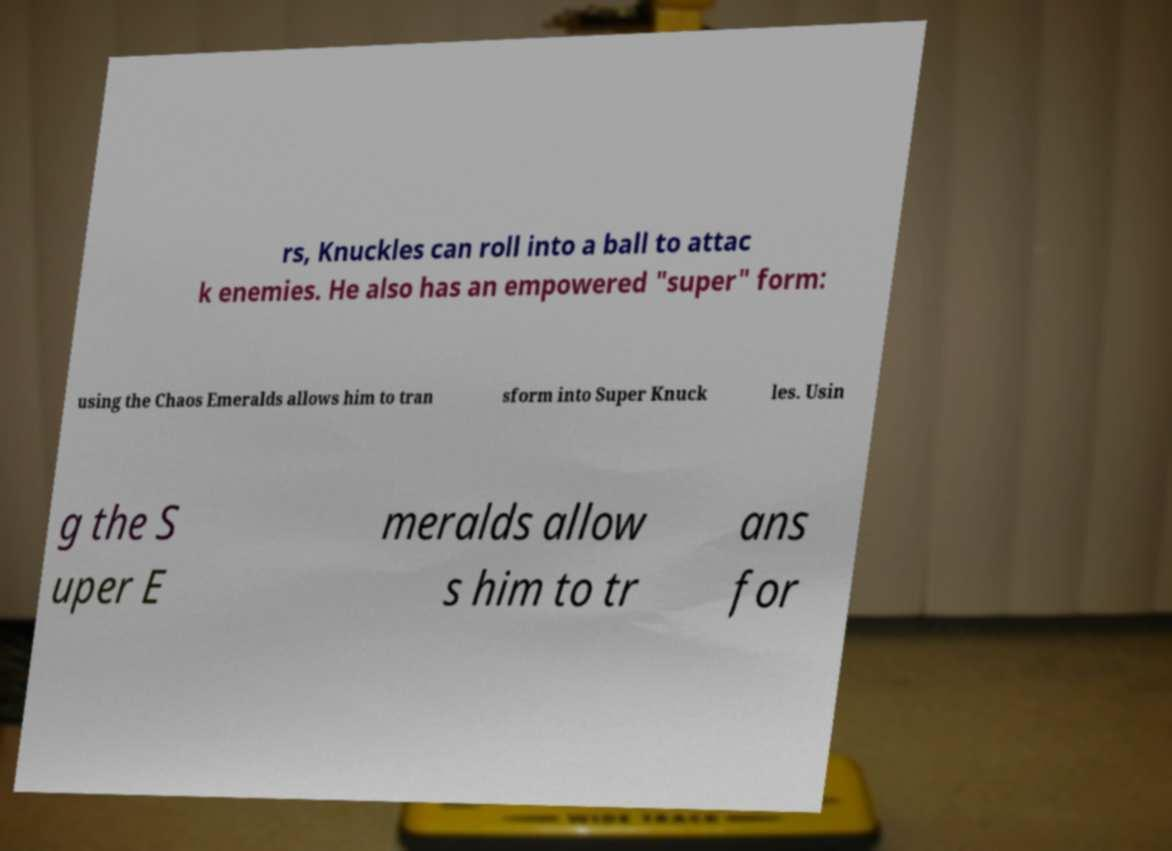What messages or text are displayed in this image? I need them in a readable, typed format. rs, Knuckles can roll into a ball to attac k enemies. He also has an empowered "super" form: using the Chaos Emeralds allows him to tran sform into Super Knuck les. Usin g the S uper E meralds allow s him to tr ans for 